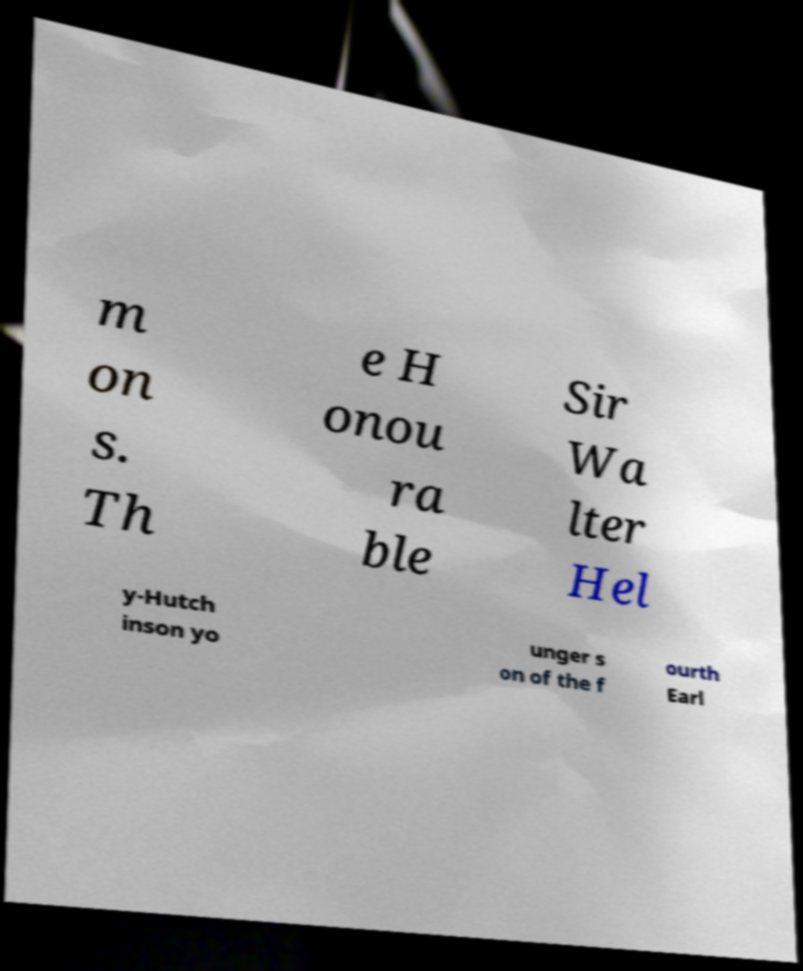What messages or text are displayed in this image? I need them in a readable, typed format. m on s. Th e H onou ra ble Sir Wa lter Hel y-Hutch inson yo unger s on of the f ourth Earl 